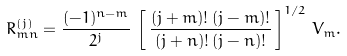Convert formula to latex. <formula><loc_0><loc_0><loc_500><loc_500>R ^ { ( j ) } _ { m n } = \frac { ( - 1 ) ^ { n - m } } { 2 ^ { j } } \, \left [ \, \frac { ( j + m ) ! \, ( j - m ) ! } { ( j + n ) ! \, ( j - n ) ! } \, \right ] ^ { 1 / 2 } \, V _ { m } .</formula> 